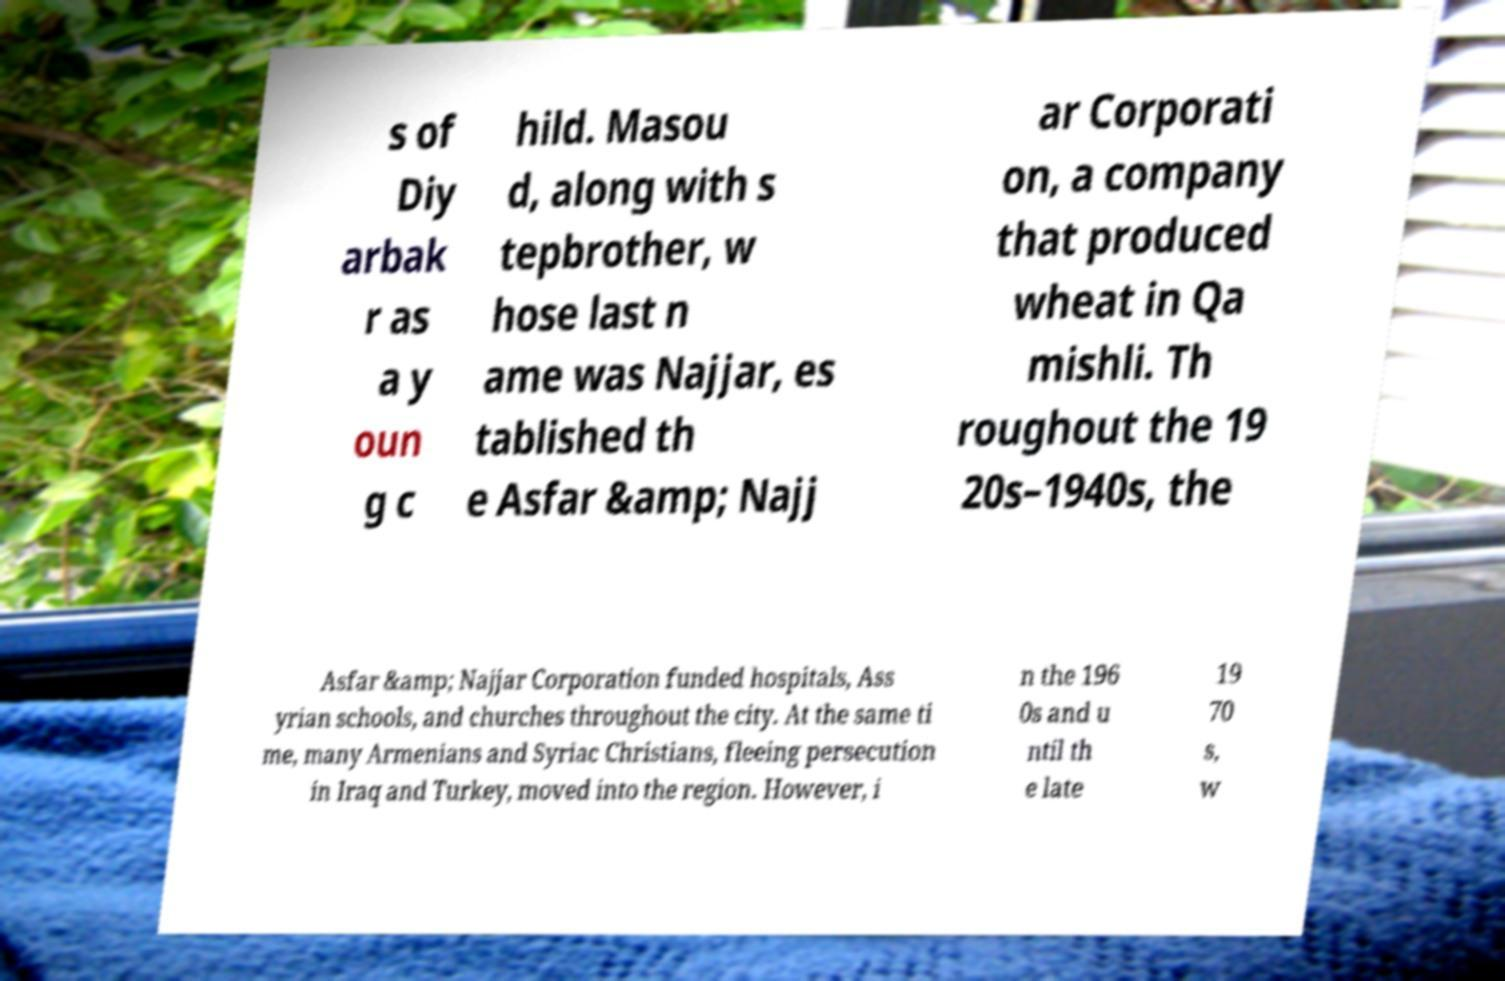Could you assist in decoding the text presented in this image and type it out clearly? s of Diy arbak r as a y oun g c hild. Masou d, along with s tepbrother, w hose last n ame was Najjar, es tablished th e Asfar &amp; Najj ar Corporati on, a company that produced wheat in Qa mishli. Th roughout the 19 20s–1940s, the Asfar &amp; Najjar Corporation funded hospitals, Ass yrian schools, and churches throughout the city. At the same ti me, many Armenians and Syriac Christians, fleeing persecution in Iraq and Turkey, moved into the region. However, i n the 196 0s and u ntil th e late 19 70 s, w 